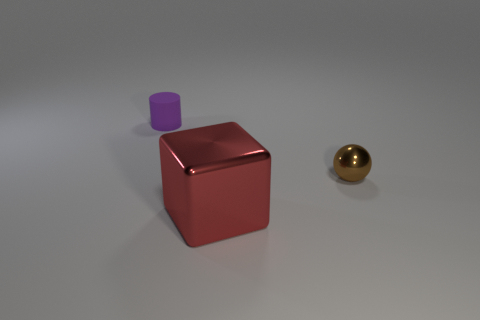Add 2 yellow rubber objects. How many objects exist? 5 Subtract all cylinders. How many objects are left? 2 Add 2 purple cylinders. How many purple cylinders are left? 3 Add 2 tiny yellow shiny things. How many tiny yellow shiny things exist? 2 Subtract 0 gray cubes. How many objects are left? 3 Subtract all big gray shiny cylinders. Subtract all small purple cylinders. How many objects are left? 2 